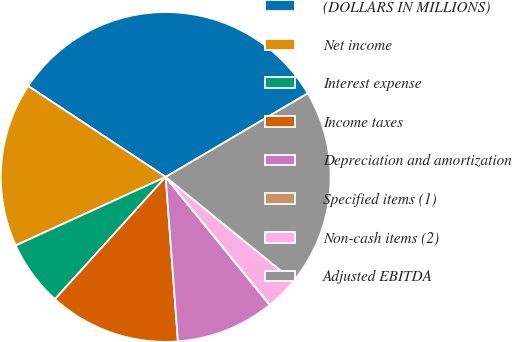Convert chart. <chart><loc_0><loc_0><loc_500><loc_500><pie_chart><fcel>(DOLLARS IN MILLIONS)<fcel>Net income<fcel>Interest expense<fcel>Income taxes<fcel>Depreciation and amortization<fcel>Specified items (1)<fcel>Non-cash items (2)<fcel>Adjusted EBITDA<nl><fcel>32.23%<fcel>16.12%<fcel>6.46%<fcel>12.9%<fcel>9.68%<fcel>0.02%<fcel>3.24%<fcel>19.34%<nl></chart> 